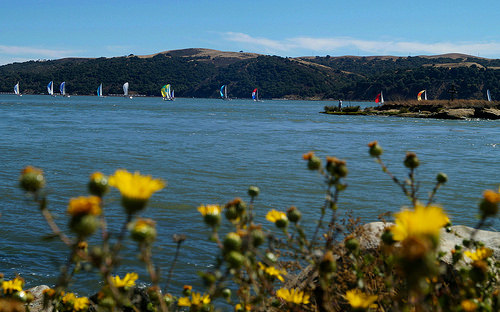<image>
Can you confirm if the sky is behind the mountain? Yes. From this viewpoint, the sky is positioned behind the mountain, with the mountain partially or fully occluding the sky. 